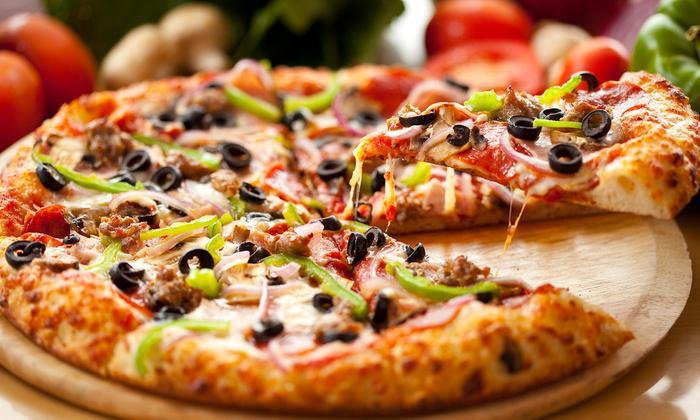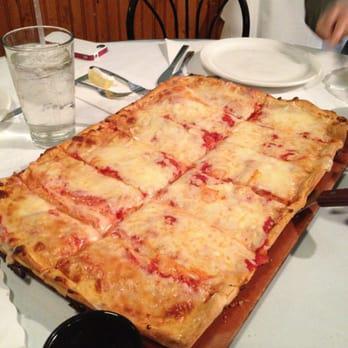The first image is the image on the left, the second image is the image on the right. Examine the images to the left and right. Is the description "All pizzas are round pizzas." accurate? Answer yes or no. No. The first image is the image on the left, the second image is the image on the right. Given the left and right images, does the statement "There are two pizzas in the right image." hold true? Answer yes or no. No. 